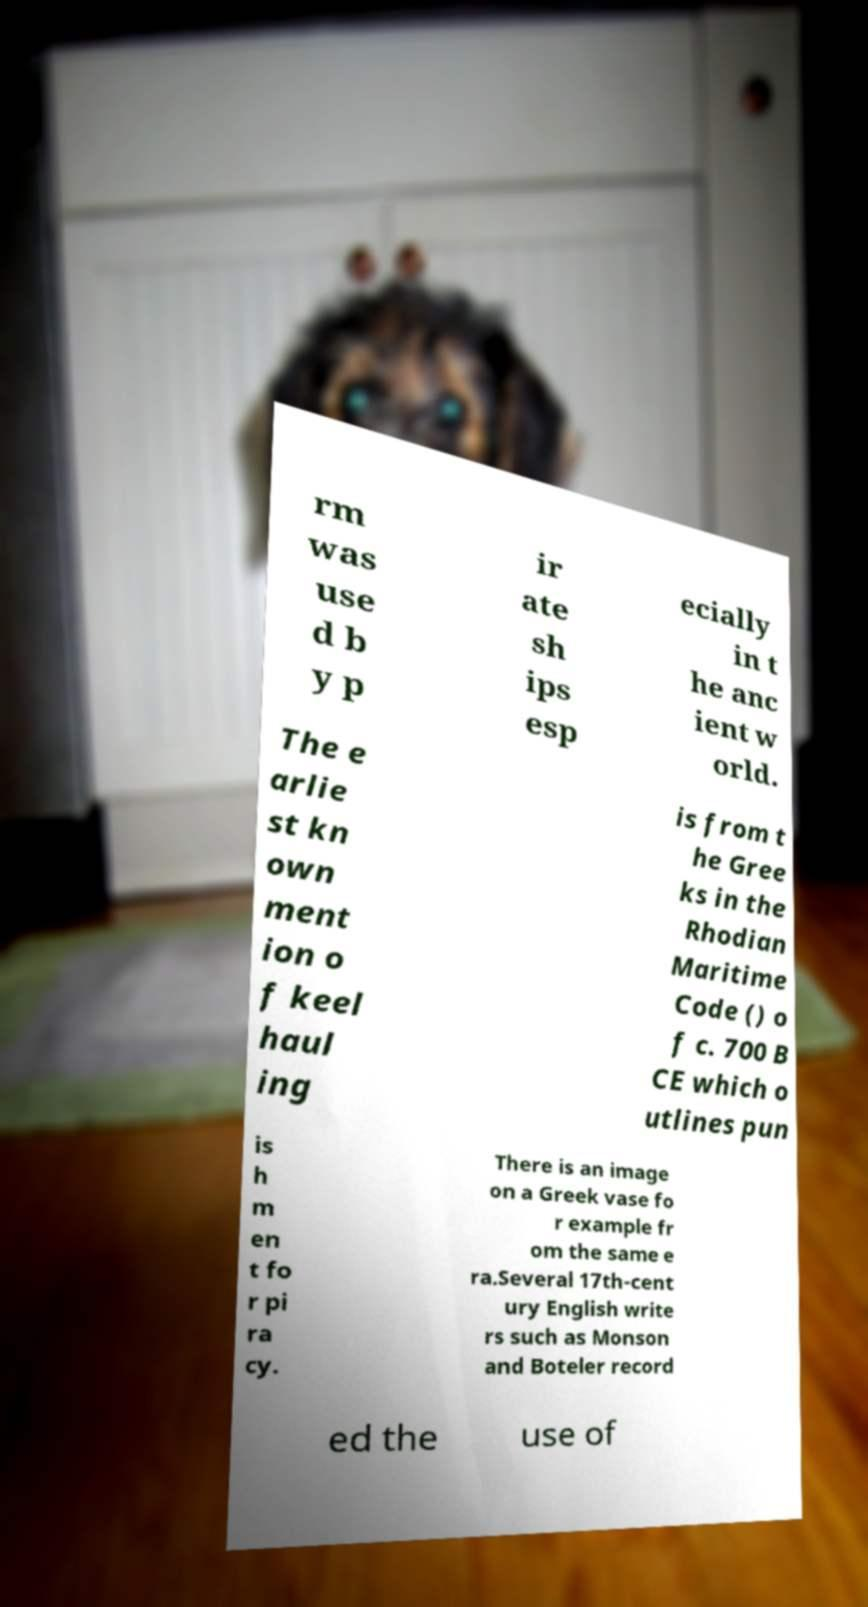Could you assist in decoding the text presented in this image and type it out clearly? rm was use d b y p ir ate sh ips esp ecially in t he anc ient w orld. The e arlie st kn own ment ion o f keel haul ing is from t he Gree ks in the Rhodian Maritime Code () o f c. 700 B CE which o utlines pun is h m en t fo r pi ra cy. There is an image on a Greek vase fo r example fr om the same e ra.Several 17th-cent ury English write rs such as Monson and Boteler record ed the use of 